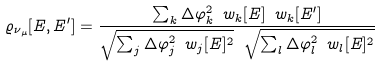<formula> <loc_0><loc_0><loc_500><loc_500>\varrho _ { \nu _ { \mu } } [ E , E ^ { \prime } ] = \frac { \sum _ { k } \Delta \varphi _ { k } ^ { 2 } \ w _ { k } [ E ] \ w _ { k } [ E ^ { \prime } ] } { \sqrt { \sum _ { j } \Delta \varphi _ { j } ^ { 2 } \ w _ { j } [ E ] ^ { 2 } } \ \sqrt { \sum _ { l } \Delta \varphi _ { l } ^ { 2 } \ w _ { l } [ E ] ^ { 2 } } }</formula> 